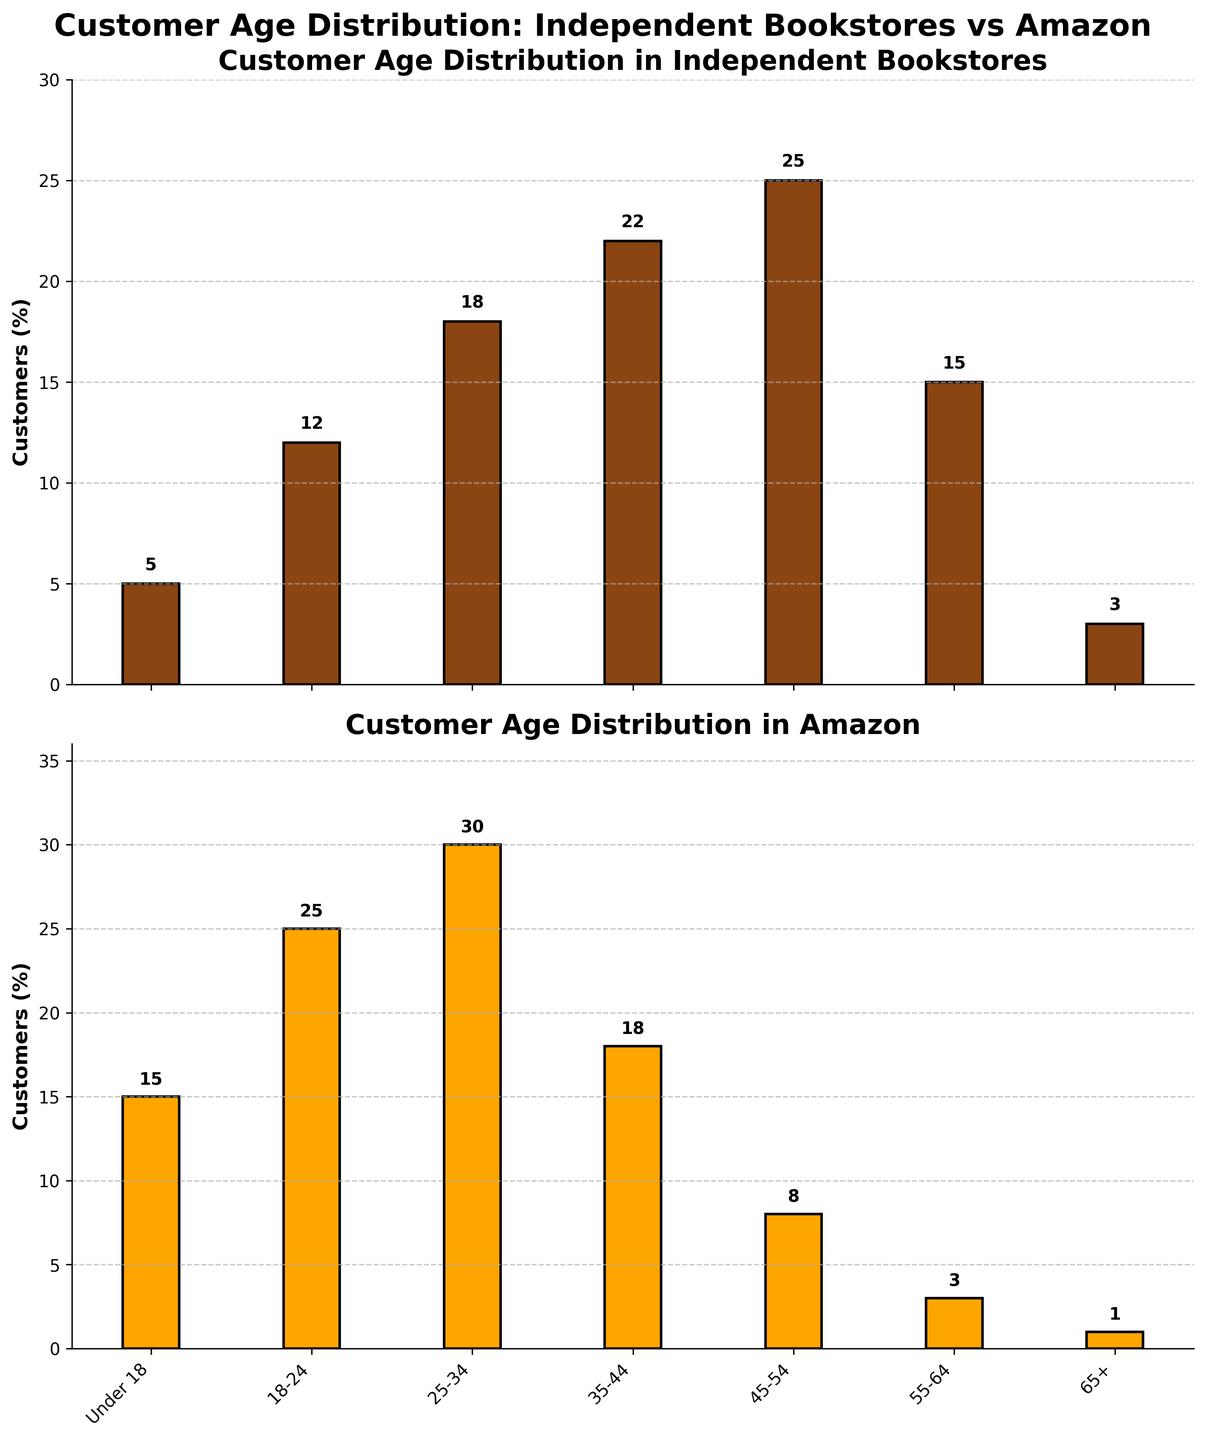What are the titles of the two subplots? The titles are visibly presented at the top of each subplot. The first subplot is titled "Customer Age Distribution in Independent Bookstores," and the second subplot is titled "Customer Age Distribution in Amazon."
Answer: "Customer Age Distribution in Independent Bookstores" and "Customer Age Distribution in Amazon" What is the percentage of customers aged 25-34 in independent bookstores? Look at the first subplot and find the bar labeled "25-34." The height of the bar indicates the percentage, which is labeled as 18.
Answer: 18% Which age group has the highest percentage of customers in independent bookstores, and what is that percentage? In the first subplot, identify the tallest bar, which corresponds to the "45-54" age group. The percentage is labeled on the bar as 25.
Answer: 45-54, 25% How does the percentage of customers aged 55-64 differ between independent bookstores and Amazon? In the first subplot, find the bar for the "55-64" age group and note the height (15%). Do the same in the second subplot (3%). Calculate the difference: 15 - 3.
Answer: 12% What is the total percentage of customers under 18 for both independent bookstores and Amazon? In both subplots, find the bars for the "Under 18" age group. The percentages are 5% for independent bookstores and 15% for Amazon. Add these values: 5 + 15.
Answer: 20% Which retailer has a higher percentage of customers in the 18-24 age group? Compare the heights of the bars for the "18-24" age group in both subplots. The height in the first subplot for independent bookstores is 12%, while the height in the second subplot for Amazon is 25%.
Answer: Amazon What is the range of customer percentages in independent bookstores? Identify the minimum and maximum values in the first subplot. The minimum is 3% (65+), and the maximum is 25% (45-54). Calculate the range: 25 - 3.
Answer: 22% Which age group has the same percentage of customers for both independent bookstores and Amazon? Observe the heights of the bars across both subplots. For the "65+" age group, the percentage is 3% in independent bookstores and 1% in Amazon. All other groups have different percentages.
Answer: None In which age group is the disparity in percentages between independent bookstores and Amazon the largest? Calculate the absolute differences for each age group: Under 18 (10), 18-24 (13), 25-34 (12), 35-44 (4), 45-54 (17), 55-64 (12), 65+ (2). The largest difference is 17 between the "45-54" group.
Answer: 45-54 What is the average percentage of customers across all age groups for Amazon? Sum the percentages for all bars in the second subplot: 15 + 25 + 30 + 18 + 8 + 3 + 1. Then divide by the number of age groups (7). (100 / 7) ≈ 14.3.
Answer: 14.3% 